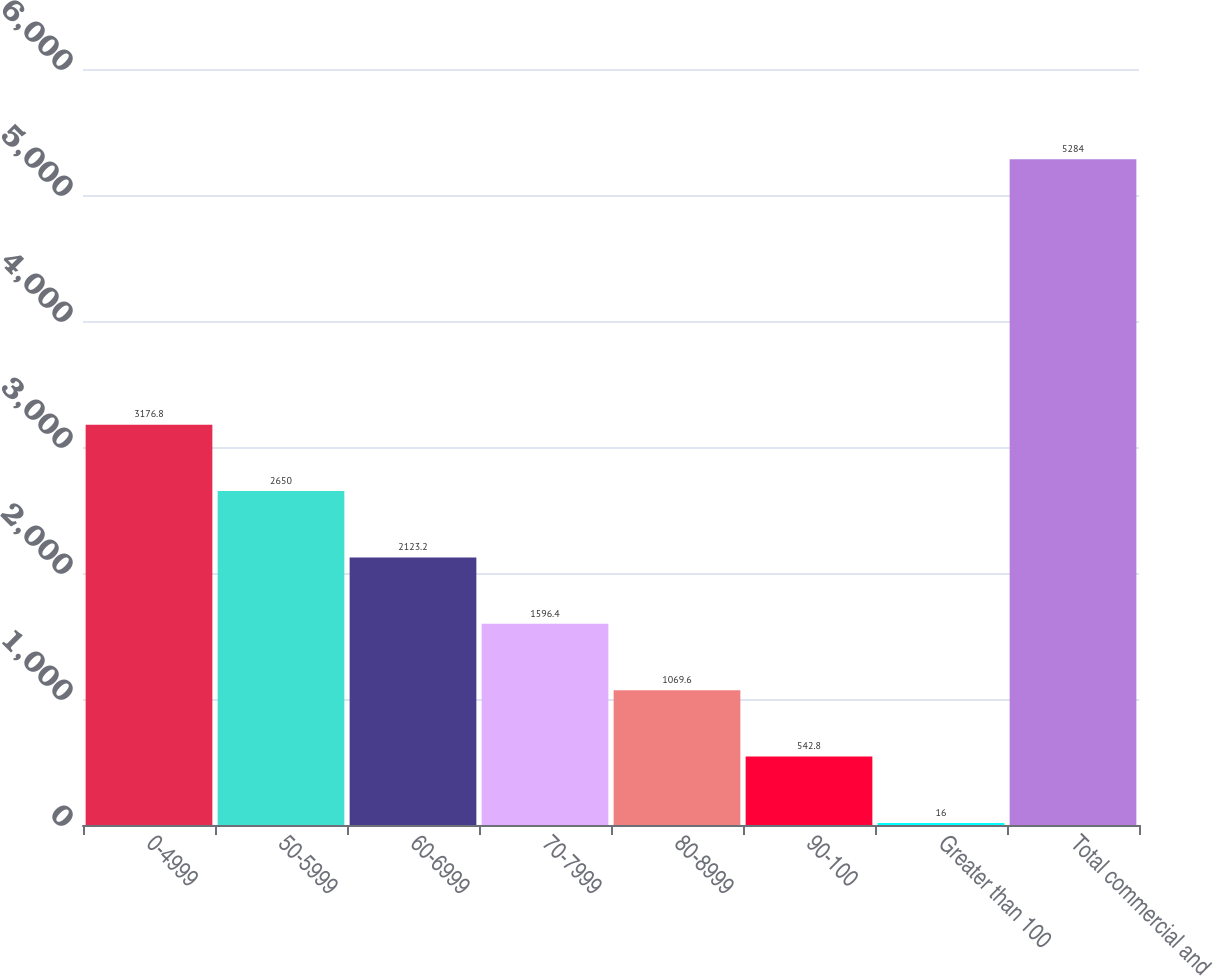<chart> <loc_0><loc_0><loc_500><loc_500><bar_chart><fcel>0-4999<fcel>50-5999<fcel>60-6999<fcel>70-7999<fcel>80-8999<fcel>90-100<fcel>Greater than 100<fcel>Total commercial and<nl><fcel>3176.8<fcel>2650<fcel>2123.2<fcel>1596.4<fcel>1069.6<fcel>542.8<fcel>16<fcel>5284<nl></chart> 